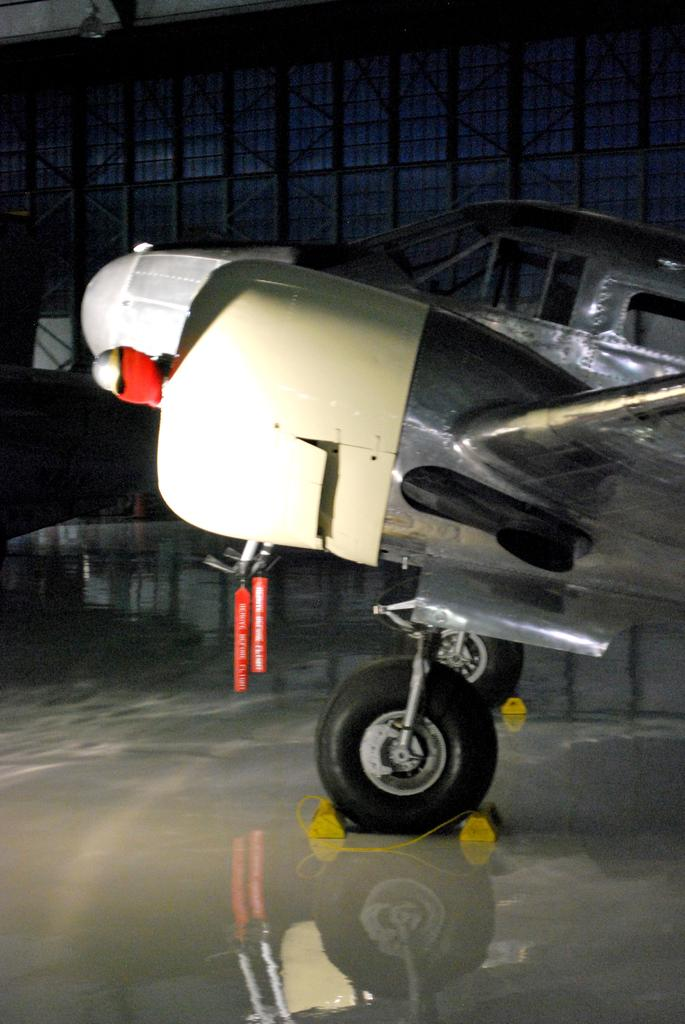What is the main subject of the image? The main subject of the image is a jet plane. Where is the jet plane located in the image? The jet plane is parked on the road in the image. What is the color of the jet plane? The jet plane is white in color. What can be seen in the background of the image? There is a wall in the background of the image. How many hydrants are visible in the image? There are no hydrants visible in the image; it only features a jet plane parked on the road. What type of government is depicted in the image? There is no depiction of a government in the image; it only shows a jet plane parked on the road. 